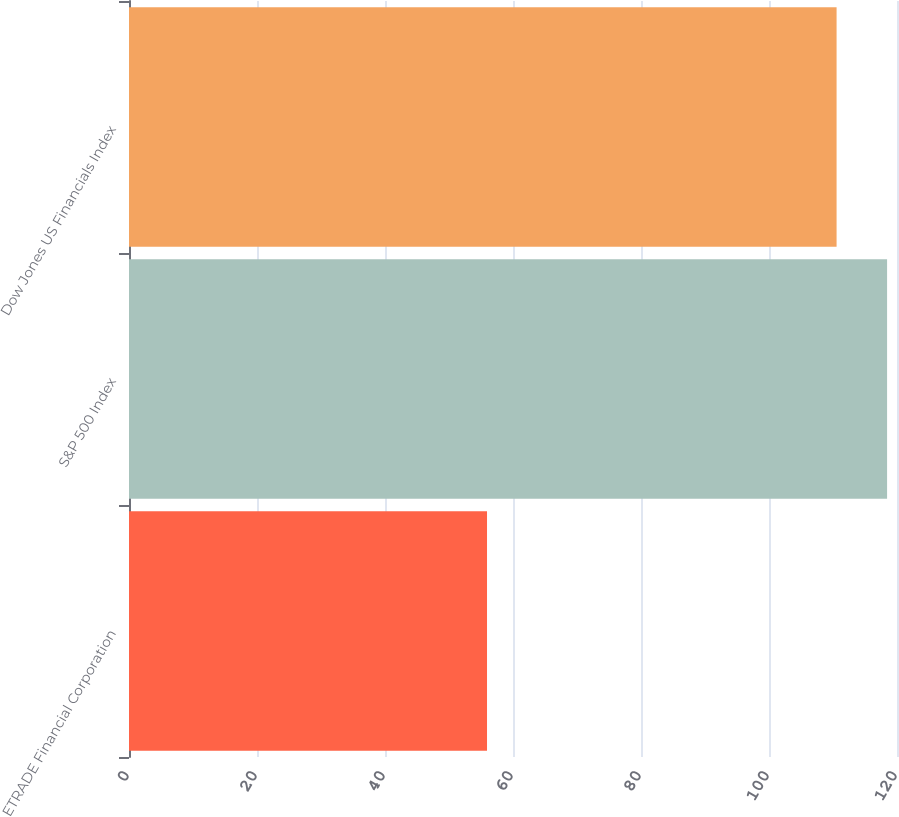Convert chart to OTSL. <chart><loc_0><loc_0><loc_500><loc_500><bar_chart><fcel>ETRADE Financial Corporation<fcel>S&P 500 Index<fcel>Dow Jones US Financials Index<nl><fcel>55.94<fcel>118.45<fcel>110.56<nl></chart> 